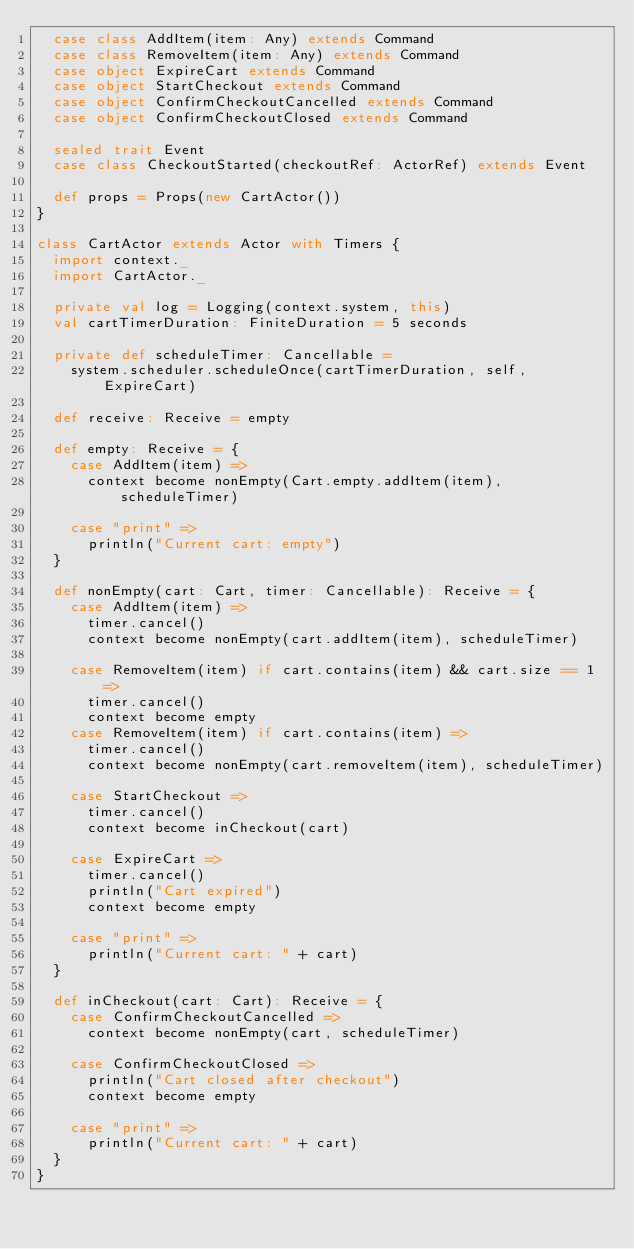Convert code to text. <code><loc_0><loc_0><loc_500><loc_500><_Scala_>  case class AddItem(item: Any) extends Command
  case class RemoveItem(item: Any) extends Command
  case object ExpireCart extends Command
  case object StartCheckout extends Command
  case object ConfirmCheckoutCancelled extends Command
  case object ConfirmCheckoutClosed extends Command

  sealed trait Event
  case class CheckoutStarted(checkoutRef: ActorRef) extends Event

  def props = Props(new CartActor())
}

class CartActor extends Actor with Timers {
  import context._
  import CartActor._

  private val log = Logging(context.system, this)
  val cartTimerDuration: FiniteDuration = 5 seconds

  private def scheduleTimer: Cancellable =
    system.scheduler.scheduleOnce(cartTimerDuration, self, ExpireCart)

  def receive: Receive = empty

  def empty: Receive = {
    case AddItem(item) =>
      context become nonEmpty(Cart.empty.addItem(item), scheduleTimer)

    case "print" =>
      println("Current cart: empty")
  }

  def nonEmpty(cart: Cart, timer: Cancellable): Receive = {
    case AddItem(item) =>
      timer.cancel()
      context become nonEmpty(cart.addItem(item), scheduleTimer)

    case RemoveItem(item) if cart.contains(item) && cart.size == 1 =>
      timer.cancel()
      context become empty
    case RemoveItem(item) if cart.contains(item) =>
      timer.cancel()
      context become nonEmpty(cart.removeItem(item), scheduleTimer)

    case StartCheckout =>
      timer.cancel()
      context become inCheckout(cart)

    case ExpireCart =>
      timer.cancel()
      println("Cart expired")
      context become empty

    case "print" =>
      println("Current cart: " + cart)
  }

  def inCheckout(cart: Cart): Receive = {
    case ConfirmCheckoutCancelled =>
      context become nonEmpty(cart, scheduleTimer)

    case ConfirmCheckoutClosed =>
      println("Cart closed after checkout")
      context become empty

    case "print" =>
      println("Current cart: " + cart)
  }
}
</code> 